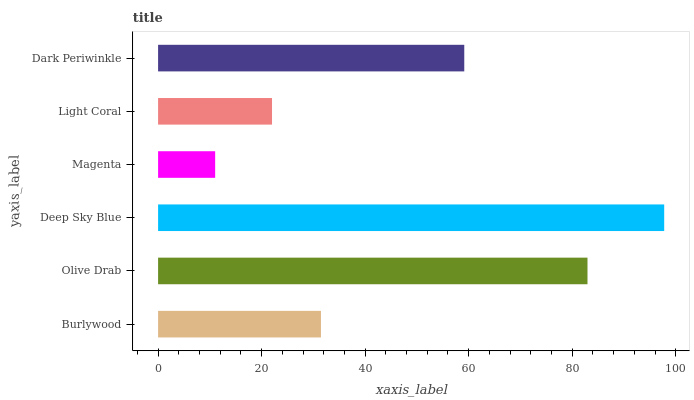Is Magenta the minimum?
Answer yes or no. Yes. Is Deep Sky Blue the maximum?
Answer yes or no. Yes. Is Olive Drab the minimum?
Answer yes or no. No. Is Olive Drab the maximum?
Answer yes or no. No. Is Olive Drab greater than Burlywood?
Answer yes or no. Yes. Is Burlywood less than Olive Drab?
Answer yes or no. Yes. Is Burlywood greater than Olive Drab?
Answer yes or no. No. Is Olive Drab less than Burlywood?
Answer yes or no. No. Is Dark Periwinkle the high median?
Answer yes or no. Yes. Is Burlywood the low median?
Answer yes or no. Yes. Is Olive Drab the high median?
Answer yes or no. No. Is Olive Drab the low median?
Answer yes or no. No. 